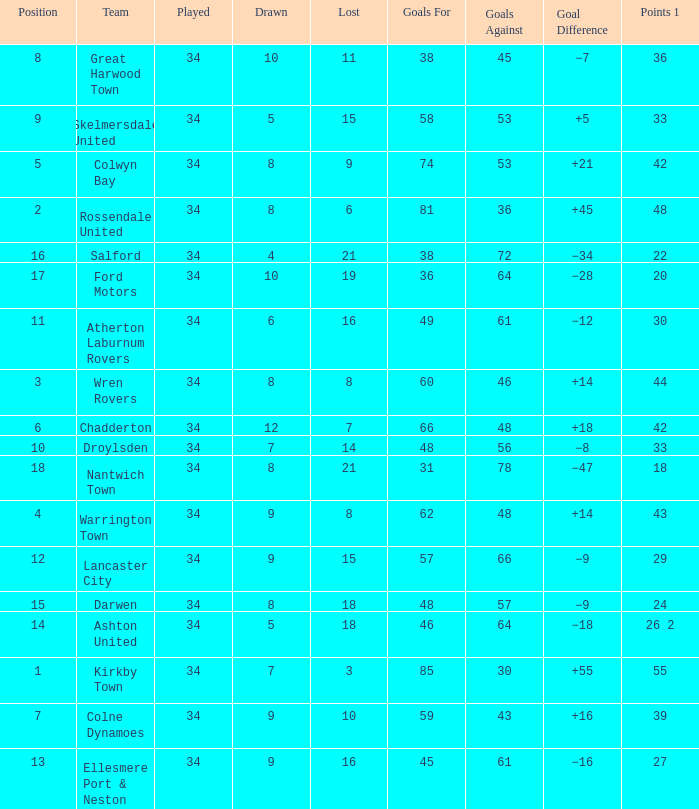What is the total number of positions when there are more than 48 goals against, 1 of 29 points are played, and less than 34 games have been played? 0.0. Parse the table in full. {'header': ['Position', 'Team', 'Played', 'Drawn', 'Lost', 'Goals For', 'Goals Against', 'Goal Difference', 'Points 1'], 'rows': [['8', 'Great Harwood Town', '34', '10', '11', '38', '45', '−7', '36'], ['9', 'Skelmersdale United', '34', '5', '15', '58', '53', '+5', '33'], ['5', 'Colwyn Bay', '34', '8', '9', '74', '53', '+21', '42'], ['2', 'Rossendale United', '34', '8', '6', '81', '36', '+45', '48'], ['16', 'Salford', '34', '4', '21', '38', '72', '−34', '22'], ['17', 'Ford Motors', '34', '10', '19', '36', '64', '−28', '20'], ['11', 'Atherton Laburnum Rovers', '34', '6', '16', '49', '61', '−12', '30'], ['3', 'Wren Rovers', '34', '8', '8', '60', '46', '+14', '44'], ['6', 'Chadderton', '34', '12', '7', '66', '48', '+18', '42'], ['10', 'Droylsden', '34', '7', '14', '48', '56', '−8', '33'], ['18', 'Nantwich Town', '34', '8', '21', '31', '78', '−47', '18'], ['4', 'Warrington Town', '34', '9', '8', '62', '48', '+14', '43'], ['12', 'Lancaster City', '34', '9', '15', '57', '66', '−9', '29'], ['15', 'Darwen', '34', '8', '18', '48', '57', '−9', '24'], ['14', 'Ashton United', '34', '5', '18', '46', '64', '−18', '26 2'], ['1', 'Kirkby Town', '34', '7', '3', '85', '30', '+55', '55'], ['7', 'Colne Dynamoes', '34', '9', '10', '59', '43', '+16', '39'], ['13', 'Ellesmere Port & Neston', '34', '9', '16', '45', '61', '−16', '27']]} 